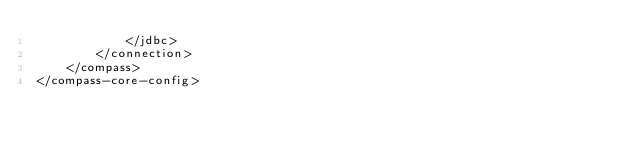<code> <loc_0><loc_0><loc_500><loc_500><_XML_>            </jdbc>
        </connection>
    </compass>
</compass-core-config></code> 